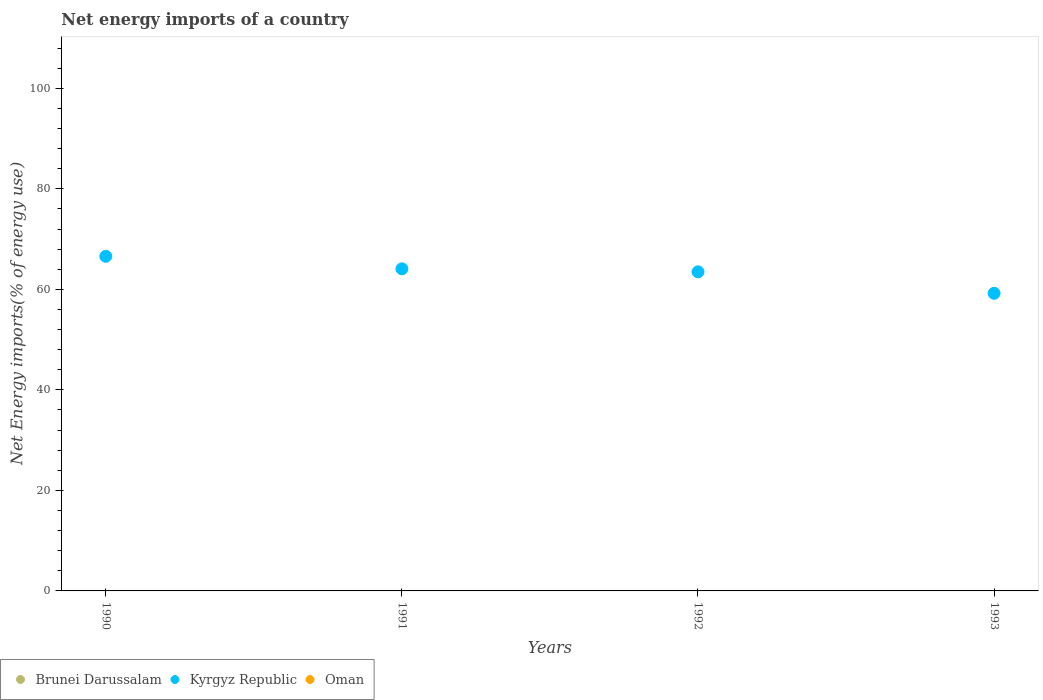Across all years, what is the maximum net energy imports in Kyrgyz Republic?
Provide a succinct answer. 66.58. Across all years, what is the minimum net energy imports in Kyrgyz Republic?
Your response must be concise. 59.22. In which year was the net energy imports in Kyrgyz Republic maximum?
Give a very brief answer. 1990. What is the total net energy imports in Oman in the graph?
Your response must be concise. 0. What is the difference between the net energy imports in Kyrgyz Republic in 1990 and that in 1992?
Offer a terse response. 3.09. What is the difference between the net energy imports in Kyrgyz Republic in 1991 and the net energy imports in Oman in 1990?
Offer a terse response. 64.09. In how many years, is the net energy imports in Brunei Darussalam greater than 12 %?
Your answer should be compact. 0. What is the ratio of the net energy imports in Kyrgyz Republic in 1991 to that in 1993?
Make the answer very short. 1.08. Is the net energy imports in Kyrgyz Republic in 1991 less than that in 1993?
Your response must be concise. No. What is the difference between the highest and the second highest net energy imports in Kyrgyz Republic?
Your answer should be compact. 2.49. What is the difference between the highest and the lowest net energy imports in Kyrgyz Republic?
Offer a very short reply. 7.36. Is the net energy imports in Oman strictly less than the net energy imports in Brunei Darussalam over the years?
Your response must be concise. No. Are the values on the major ticks of Y-axis written in scientific E-notation?
Keep it short and to the point. No. Does the graph contain any zero values?
Ensure brevity in your answer.  Yes. Does the graph contain grids?
Give a very brief answer. No. How many legend labels are there?
Ensure brevity in your answer.  3. What is the title of the graph?
Your response must be concise. Net energy imports of a country. What is the label or title of the X-axis?
Offer a terse response. Years. What is the label or title of the Y-axis?
Offer a very short reply. Net Energy imports(% of energy use). What is the Net Energy imports(% of energy use) in Kyrgyz Republic in 1990?
Offer a very short reply. 66.58. What is the Net Energy imports(% of energy use) in Oman in 1990?
Ensure brevity in your answer.  0. What is the Net Energy imports(% of energy use) in Kyrgyz Republic in 1991?
Your answer should be very brief. 64.09. What is the Net Energy imports(% of energy use) of Oman in 1991?
Keep it short and to the point. 0. What is the Net Energy imports(% of energy use) of Kyrgyz Republic in 1992?
Make the answer very short. 63.49. What is the Net Energy imports(% of energy use) in Oman in 1992?
Ensure brevity in your answer.  0. What is the Net Energy imports(% of energy use) in Brunei Darussalam in 1993?
Your response must be concise. 0. What is the Net Energy imports(% of energy use) of Kyrgyz Republic in 1993?
Provide a succinct answer. 59.22. What is the Net Energy imports(% of energy use) of Oman in 1993?
Offer a terse response. 0. Across all years, what is the maximum Net Energy imports(% of energy use) in Kyrgyz Republic?
Offer a very short reply. 66.58. Across all years, what is the minimum Net Energy imports(% of energy use) of Kyrgyz Republic?
Provide a short and direct response. 59.22. What is the total Net Energy imports(% of energy use) of Kyrgyz Republic in the graph?
Ensure brevity in your answer.  253.37. What is the difference between the Net Energy imports(% of energy use) of Kyrgyz Republic in 1990 and that in 1991?
Provide a short and direct response. 2.49. What is the difference between the Net Energy imports(% of energy use) in Kyrgyz Republic in 1990 and that in 1992?
Give a very brief answer. 3.09. What is the difference between the Net Energy imports(% of energy use) in Kyrgyz Republic in 1990 and that in 1993?
Your answer should be compact. 7.36. What is the difference between the Net Energy imports(% of energy use) in Kyrgyz Republic in 1991 and that in 1992?
Offer a very short reply. 0.6. What is the difference between the Net Energy imports(% of energy use) in Kyrgyz Republic in 1991 and that in 1993?
Offer a terse response. 4.87. What is the difference between the Net Energy imports(% of energy use) in Kyrgyz Republic in 1992 and that in 1993?
Provide a succinct answer. 4.27. What is the average Net Energy imports(% of energy use) of Kyrgyz Republic per year?
Ensure brevity in your answer.  63.34. What is the ratio of the Net Energy imports(% of energy use) in Kyrgyz Republic in 1990 to that in 1991?
Provide a short and direct response. 1.04. What is the ratio of the Net Energy imports(% of energy use) in Kyrgyz Republic in 1990 to that in 1992?
Make the answer very short. 1.05. What is the ratio of the Net Energy imports(% of energy use) of Kyrgyz Republic in 1990 to that in 1993?
Your answer should be compact. 1.12. What is the ratio of the Net Energy imports(% of energy use) in Kyrgyz Republic in 1991 to that in 1992?
Ensure brevity in your answer.  1.01. What is the ratio of the Net Energy imports(% of energy use) in Kyrgyz Republic in 1991 to that in 1993?
Ensure brevity in your answer.  1.08. What is the ratio of the Net Energy imports(% of energy use) of Kyrgyz Republic in 1992 to that in 1993?
Provide a succinct answer. 1.07. What is the difference between the highest and the second highest Net Energy imports(% of energy use) of Kyrgyz Republic?
Keep it short and to the point. 2.49. What is the difference between the highest and the lowest Net Energy imports(% of energy use) in Kyrgyz Republic?
Your response must be concise. 7.36. 